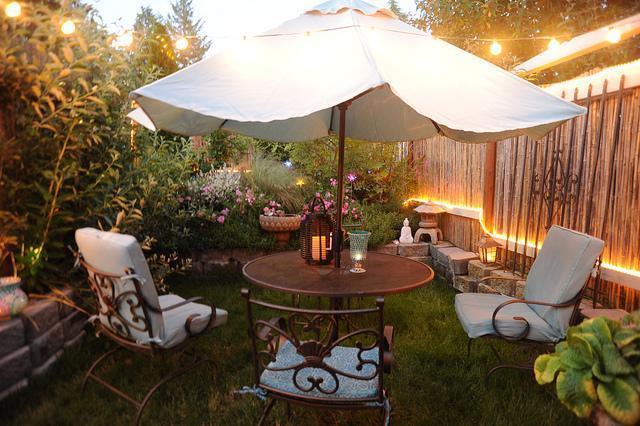How many chairs are near the patio table?
Give a very brief answer. 3. How many potted plants are visible?
Give a very brief answer. 3. How many chairs are there?
Give a very brief answer. 3. How many giraffe are there?
Give a very brief answer. 0. 